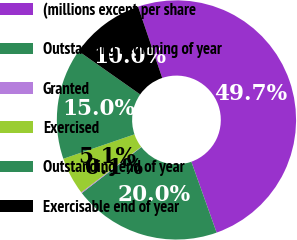Convert chart. <chart><loc_0><loc_0><loc_500><loc_500><pie_chart><fcel>(millions except per share<fcel>Outstanding beginning of year<fcel>Granted<fcel>Exercised<fcel>Outstanding end of year<fcel>Exercisable end of year<nl><fcel>49.75%<fcel>19.98%<fcel>0.12%<fcel>5.09%<fcel>15.01%<fcel>10.05%<nl></chart> 